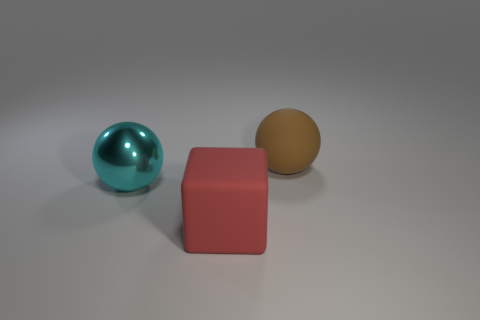Add 3 red rubber cubes. How many objects exist? 6 Subtract all cubes. How many objects are left? 2 Add 2 big red blocks. How many big red blocks are left? 3 Add 2 green metal things. How many green metal things exist? 2 Subtract 1 cyan balls. How many objects are left? 2 Subtract all small gray things. Subtract all brown balls. How many objects are left? 2 